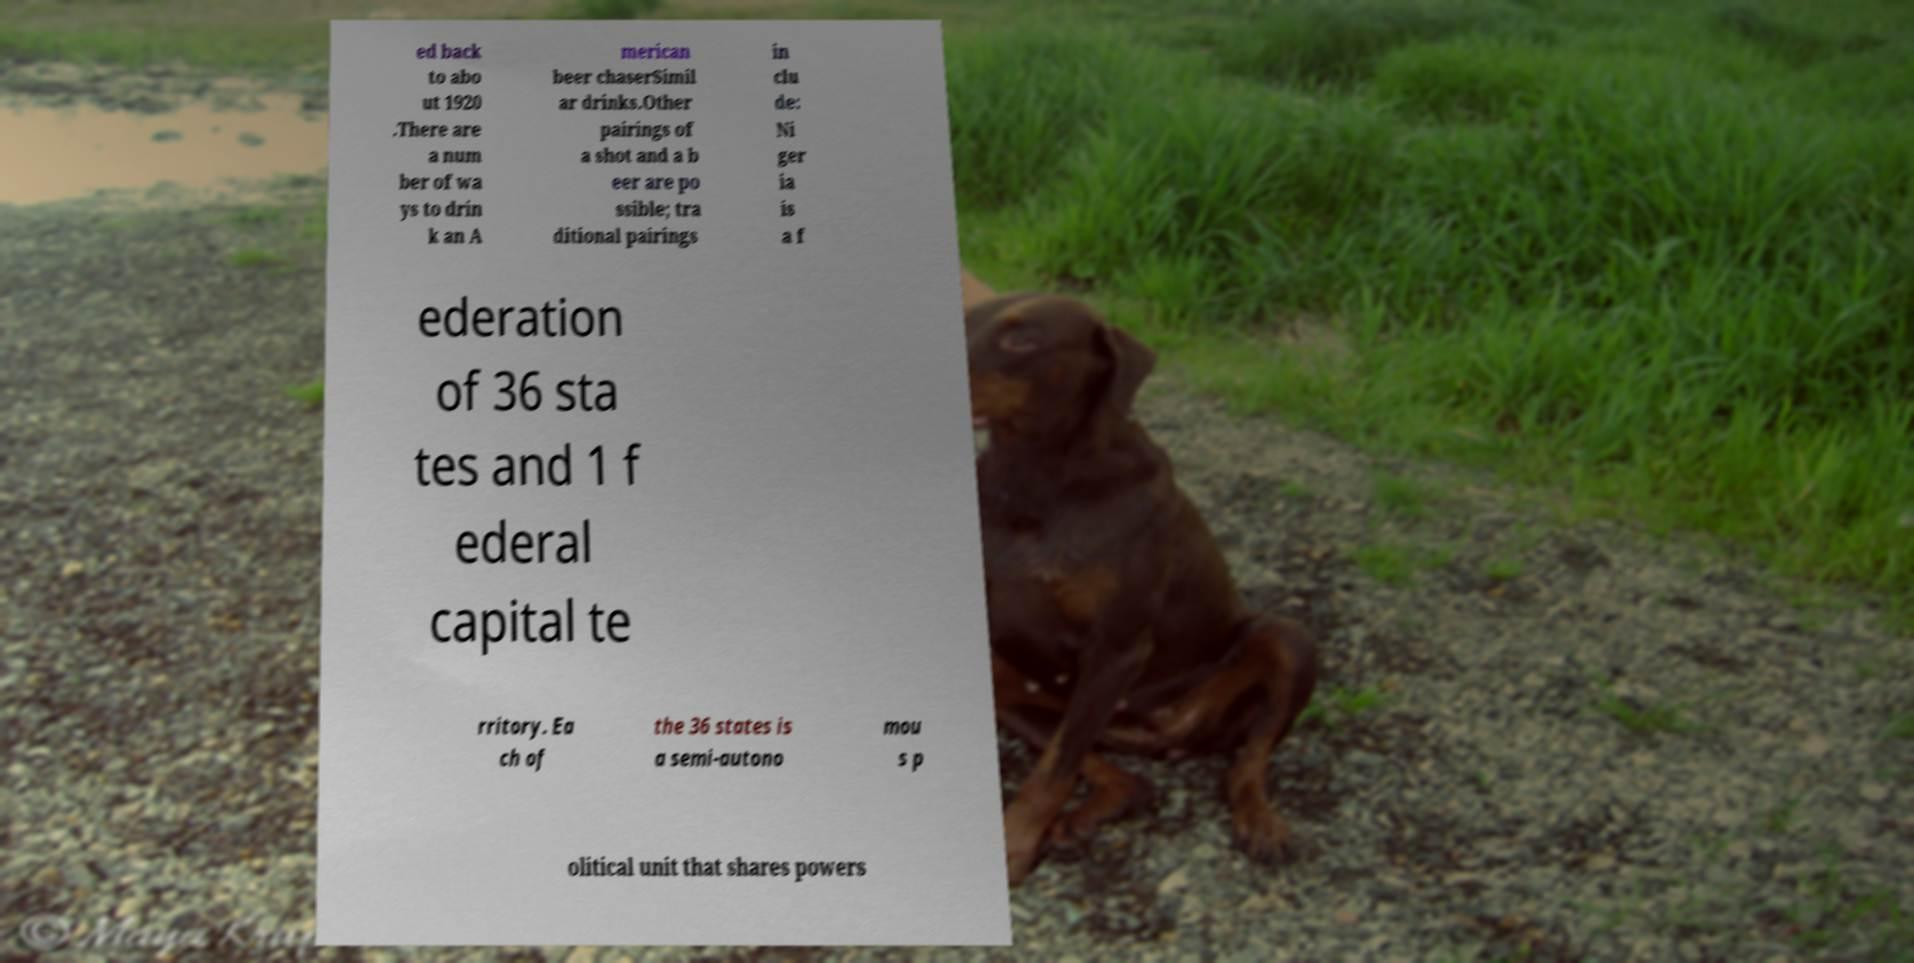There's text embedded in this image that I need extracted. Can you transcribe it verbatim? ed back to abo ut 1920 .There are a num ber of wa ys to drin k an A merican beer chaserSimil ar drinks.Other pairings of a shot and a b eer are po ssible; tra ditional pairings in clu de: Ni ger ia is a f ederation of 36 sta tes and 1 f ederal capital te rritory. Ea ch of the 36 states is a semi-autono mou s p olitical unit that shares powers 